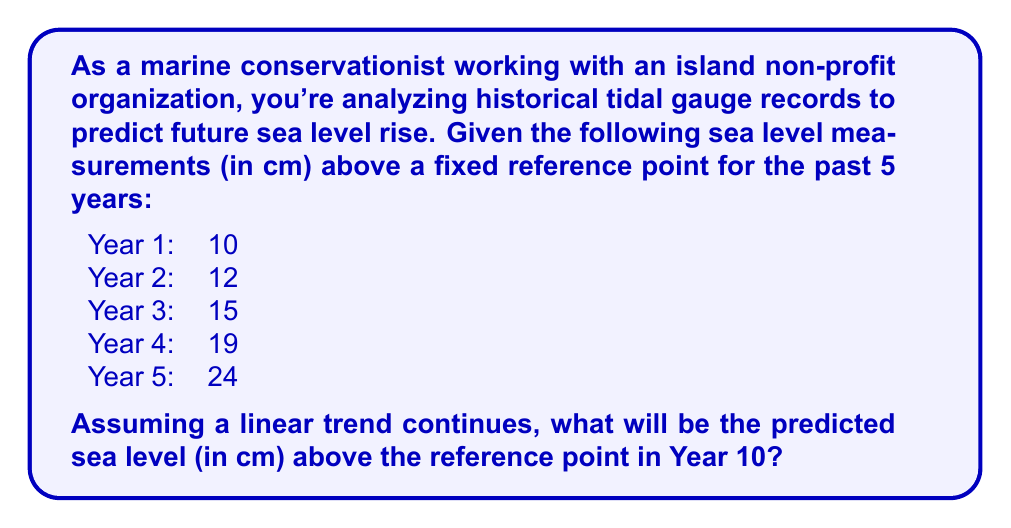Show me your answer to this math problem. To solve this problem, we'll use linear regression to find the best-fit line for the given data and then extrapolate to predict the sea level in Year 10.

Step 1: Set up the linear equation
Let $y$ represent the sea level and $x$ represent the year number.
The linear equation is of the form: $y = mx + b$, where $m$ is the slope and $b$ is the y-intercept.

Step 2: Calculate the slope $m$
Using the first and last data points:
$m = \frac{y_2 - y_1}{x_2 - x_1} = \frac{24 - 10}{5 - 1} = \frac{14}{4} = 3.5$ cm/year

Step 3: Find the y-intercept $b$
Use any point, let's use (1, 10):
$10 = 3.5(1) + b$
$b = 10 - 3.5 = 6.5$

Step 4: Write the linear equation
$y = 3.5x + 6.5$

Step 5: Predict the sea level for Year 10
Substitute $x = 10$ into the equation:
$y = 3.5(10) + 6.5 = 35 + 6.5 = 41.5$

Therefore, the predicted sea level in Year 10 will be 41.5 cm above the reference point.
Answer: 41.5 cm 